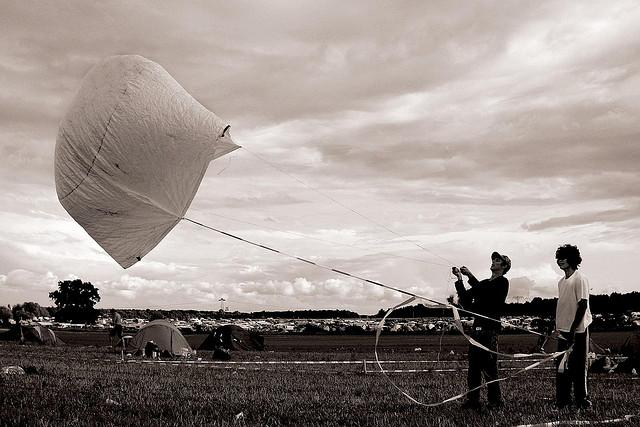What are the two men doing?
Write a very short answer. Flying kite. How many people are in the picture?
Write a very short answer. 2. Is this a gloomy type day?
Keep it brief. Yes. 